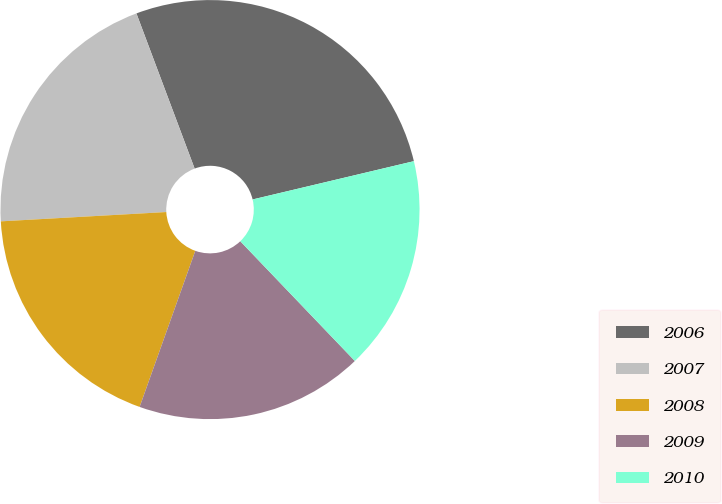Convert chart to OTSL. <chart><loc_0><loc_0><loc_500><loc_500><pie_chart><fcel>2006<fcel>2007<fcel>2008<fcel>2009<fcel>2010<nl><fcel>27.0%<fcel>20.18%<fcel>18.65%<fcel>17.6%<fcel>16.56%<nl></chart> 